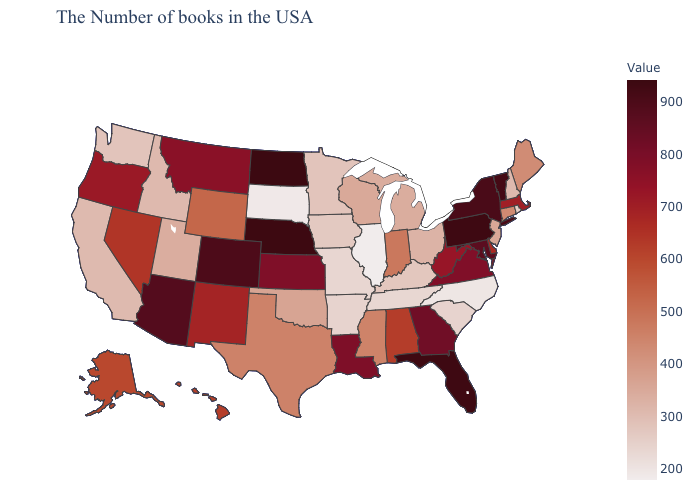Does Wyoming have the lowest value in the West?
Short answer required. No. Does Illinois have the lowest value in the USA?
Keep it brief. Yes. Among the states that border Kansas , does Nebraska have the lowest value?
Give a very brief answer. No. Which states have the lowest value in the USA?
Be succinct. Illinois. Which states have the highest value in the USA?
Concise answer only. North Dakota. Among the states that border California , does Arizona have the highest value?
Short answer required. Yes. Does New Hampshire have the lowest value in the Northeast?
Concise answer only. No. 